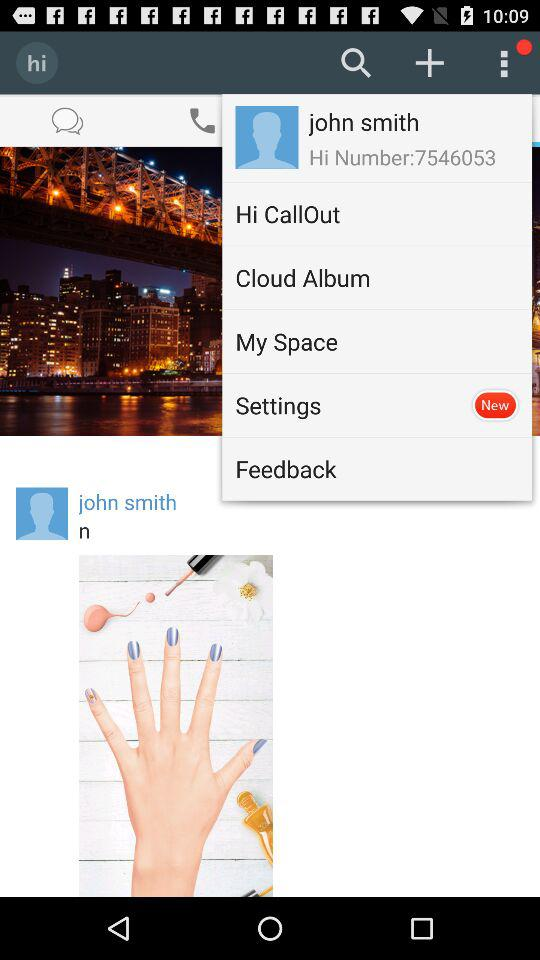What is the given "Hi Number"? The given "Hi Number" is 7546053. 